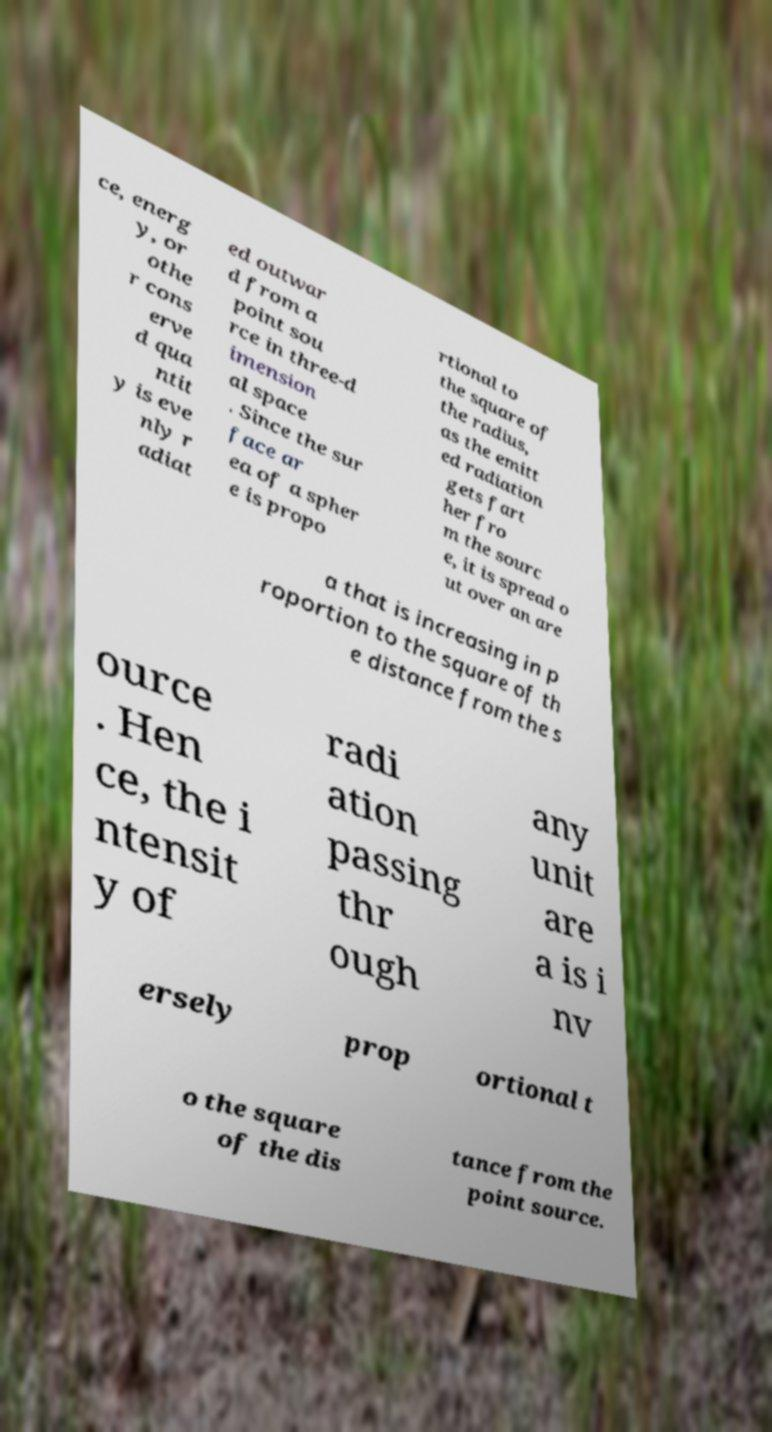Can you read and provide the text displayed in the image?This photo seems to have some interesting text. Can you extract and type it out for me? ce, energ y, or othe r cons erve d qua ntit y is eve nly r adiat ed outwar d from a point sou rce in three-d imension al space . Since the sur face ar ea of a spher e is propo rtional to the square of the radius, as the emitt ed radiation gets fart her fro m the sourc e, it is spread o ut over an are a that is increasing in p roportion to the square of th e distance from the s ource . Hen ce, the i ntensit y of radi ation passing thr ough any unit are a is i nv ersely prop ortional t o the square of the dis tance from the point source. 